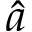<formula> <loc_0><loc_0><loc_500><loc_500>\hat { a }</formula> 